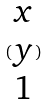Convert formula to latex. <formula><loc_0><loc_0><loc_500><loc_500>( \begin{matrix} x \\ y \\ 1 \end{matrix} )</formula> 